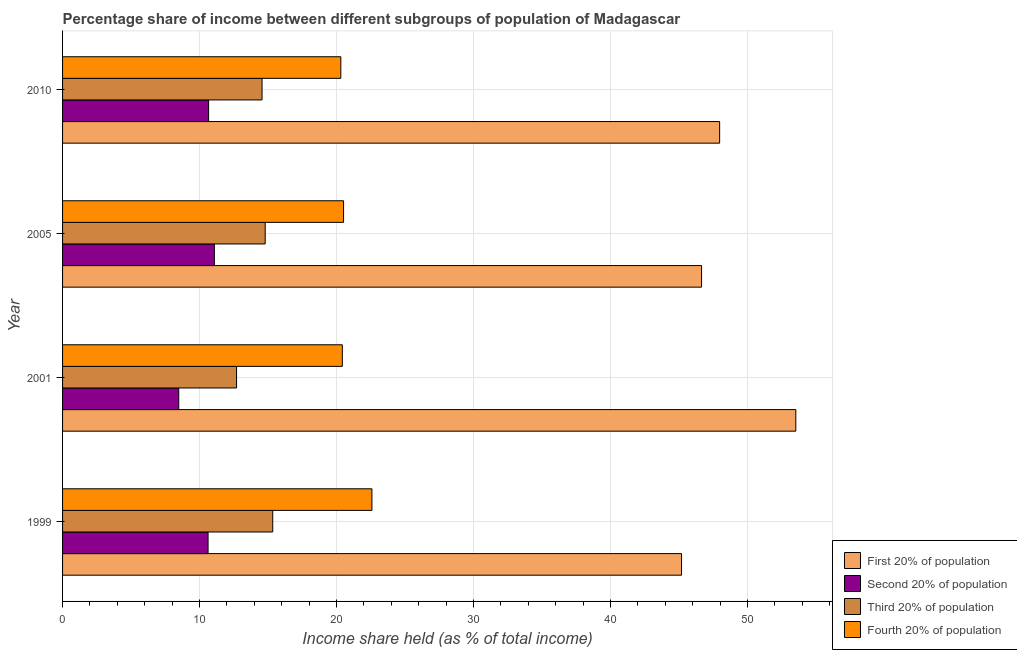How many different coloured bars are there?
Your response must be concise. 4. How many groups of bars are there?
Give a very brief answer. 4. Are the number of bars on each tick of the Y-axis equal?
Make the answer very short. Yes. How many bars are there on the 2nd tick from the bottom?
Provide a succinct answer. 4. What is the label of the 1st group of bars from the top?
Your answer should be very brief. 2010. What is the share of the income held by second 20% of the population in 2010?
Provide a succinct answer. 10.66. Across all years, what is the maximum share of the income held by first 20% of the population?
Your response must be concise. 53.52. Across all years, what is the minimum share of the income held by fourth 20% of the population?
Offer a very short reply. 20.31. What is the total share of the income held by third 20% of the population in the graph?
Offer a terse response. 57.39. What is the difference between the share of the income held by second 20% of the population in 2005 and that in 2010?
Your answer should be very brief. 0.42. What is the difference between the share of the income held by third 20% of the population in 2005 and the share of the income held by first 20% of the population in 2010?
Your answer should be compact. -33.17. What is the average share of the income held by second 20% of the population per year?
Your answer should be compact. 10.21. In the year 2005, what is the difference between the share of the income held by second 20% of the population and share of the income held by third 20% of the population?
Offer a terse response. -3.71. Is the difference between the share of the income held by second 20% of the population in 1999 and 2005 greater than the difference between the share of the income held by first 20% of the population in 1999 and 2005?
Provide a succinct answer. Yes. What is the difference between the highest and the second highest share of the income held by third 20% of the population?
Your answer should be compact. 0.55. What is the difference between the highest and the lowest share of the income held by third 20% of the population?
Ensure brevity in your answer.  2.64. Is it the case that in every year, the sum of the share of the income held by second 20% of the population and share of the income held by third 20% of the population is greater than the sum of share of the income held by first 20% of the population and share of the income held by fourth 20% of the population?
Your response must be concise. No. What does the 4th bar from the top in 2005 represents?
Provide a short and direct response. First 20% of population. What does the 3rd bar from the bottom in 1999 represents?
Your response must be concise. Third 20% of population. Is it the case that in every year, the sum of the share of the income held by first 20% of the population and share of the income held by second 20% of the population is greater than the share of the income held by third 20% of the population?
Ensure brevity in your answer.  Yes. Are all the bars in the graph horizontal?
Provide a short and direct response. Yes. Are the values on the major ticks of X-axis written in scientific E-notation?
Offer a very short reply. No. How many legend labels are there?
Make the answer very short. 4. What is the title of the graph?
Your answer should be compact. Percentage share of income between different subgroups of population of Madagascar. What is the label or title of the X-axis?
Give a very brief answer. Income share held (as % of total income). What is the label or title of the Y-axis?
Provide a succinct answer. Year. What is the Income share held (as % of total income) of First 20% of population in 1999?
Make the answer very short. 45.18. What is the Income share held (as % of total income) of Second 20% of population in 1999?
Keep it short and to the point. 10.62. What is the Income share held (as % of total income) in Third 20% of population in 1999?
Give a very brief answer. 15.34. What is the Income share held (as % of total income) of Fourth 20% of population in 1999?
Keep it short and to the point. 22.58. What is the Income share held (as % of total income) of First 20% of population in 2001?
Your response must be concise. 53.52. What is the Income share held (as % of total income) of Second 20% of population in 2001?
Provide a succinct answer. 8.48. What is the Income share held (as % of total income) in Fourth 20% of population in 2001?
Give a very brief answer. 20.42. What is the Income share held (as % of total income) of First 20% of population in 2005?
Offer a very short reply. 46.64. What is the Income share held (as % of total income) in Second 20% of population in 2005?
Provide a succinct answer. 11.08. What is the Income share held (as % of total income) of Third 20% of population in 2005?
Your response must be concise. 14.79. What is the Income share held (as % of total income) in Fourth 20% of population in 2005?
Ensure brevity in your answer.  20.51. What is the Income share held (as % of total income) in First 20% of population in 2010?
Your answer should be compact. 47.96. What is the Income share held (as % of total income) of Second 20% of population in 2010?
Your answer should be compact. 10.66. What is the Income share held (as % of total income) in Third 20% of population in 2010?
Give a very brief answer. 14.56. What is the Income share held (as % of total income) in Fourth 20% of population in 2010?
Give a very brief answer. 20.31. Across all years, what is the maximum Income share held (as % of total income) of First 20% of population?
Provide a succinct answer. 53.52. Across all years, what is the maximum Income share held (as % of total income) in Second 20% of population?
Provide a short and direct response. 11.08. Across all years, what is the maximum Income share held (as % of total income) of Third 20% of population?
Offer a terse response. 15.34. Across all years, what is the maximum Income share held (as % of total income) in Fourth 20% of population?
Your response must be concise. 22.58. Across all years, what is the minimum Income share held (as % of total income) in First 20% of population?
Offer a terse response. 45.18. Across all years, what is the minimum Income share held (as % of total income) in Second 20% of population?
Your response must be concise. 8.48. Across all years, what is the minimum Income share held (as % of total income) of Third 20% of population?
Your response must be concise. 12.7. Across all years, what is the minimum Income share held (as % of total income) of Fourth 20% of population?
Your response must be concise. 20.31. What is the total Income share held (as % of total income) of First 20% of population in the graph?
Your answer should be compact. 193.3. What is the total Income share held (as % of total income) in Second 20% of population in the graph?
Offer a very short reply. 40.84. What is the total Income share held (as % of total income) of Third 20% of population in the graph?
Provide a succinct answer. 57.39. What is the total Income share held (as % of total income) of Fourth 20% of population in the graph?
Your answer should be very brief. 83.82. What is the difference between the Income share held (as % of total income) in First 20% of population in 1999 and that in 2001?
Your response must be concise. -8.34. What is the difference between the Income share held (as % of total income) in Second 20% of population in 1999 and that in 2001?
Provide a succinct answer. 2.14. What is the difference between the Income share held (as % of total income) of Third 20% of population in 1999 and that in 2001?
Ensure brevity in your answer.  2.64. What is the difference between the Income share held (as % of total income) in Fourth 20% of population in 1999 and that in 2001?
Make the answer very short. 2.16. What is the difference between the Income share held (as % of total income) of First 20% of population in 1999 and that in 2005?
Give a very brief answer. -1.46. What is the difference between the Income share held (as % of total income) in Second 20% of population in 1999 and that in 2005?
Your answer should be compact. -0.46. What is the difference between the Income share held (as % of total income) of Third 20% of population in 1999 and that in 2005?
Your answer should be very brief. 0.55. What is the difference between the Income share held (as % of total income) in Fourth 20% of population in 1999 and that in 2005?
Offer a terse response. 2.07. What is the difference between the Income share held (as % of total income) of First 20% of population in 1999 and that in 2010?
Offer a very short reply. -2.78. What is the difference between the Income share held (as % of total income) in Second 20% of population in 1999 and that in 2010?
Offer a terse response. -0.04. What is the difference between the Income share held (as % of total income) of Third 20% of population in 1999 and that in 2010?
Ensure brevity in your answer.  0.78. What is the difference between the Income share held (as % of total income) of Fourth 20% of population in 1999 and that in 2010?
Offer a very short reply. 2.27. What is the difference between the Income share held (as % of total income) of First 20% of population in 2001 and that in 2005?
Provide a short and direct response. 6.88. What is the difference between the Income share held (as % of total income) in Second 20% of population in 2001 and that in 2005?
Your response must be concise. -2.6. What is the difference between the Income share held (as % of total income) of Third 20% of population in 2001 and that in 2005?
Give a very brief answer. -2.09. What is the difference between the Income share held (as % of total income) of Fourth 20% of population in 2001 and that in 2005?
Give a very brief answer. -0.09. What is the difference between the Income share held (as % of total income) in First 20% of population in 2001 and that in 2010?
Your answer should be very brief. 5.56. What is the difference between the Income share held (as % of total income) of Second 20% of population in 2001 and that in 2010?
Your response must be concise. -2.18. What is the difference between the Income share held (as % of total income) in Third 20% of population in 2001 and that in 2010?
Your answer should be compact. -1.86. What is the difference between the Income share held (as % of total income) in Fourth 20% of population in 2001 and that in 2010?
Provide a succinct answer. 0.11. What is the difference between the Income share held (as % of total income) in First 20% of population in 2005 and that in 2010?
Provide a succinct answer. -1.32. What is the difference between the Income share held (as % of total income) in Second 20% of population in 2005 and that in 2010?
Provide a succinct answer. 0.42. What is the difference between the Income share held (as % of total income) of Third 20% of population in 2005 and that in 2010?
Your response must be concise. 0.23. What is the difference between the Income share held (as % of total income) in Fourth 20% of population in 2005 and that in 2010?
Give a very brief answer. 0.2. What is the difference between the Income share held (as % of total income) of First 20% of population in 1999 and the Income share held (as % of total income) of Second 20% of population in 2001?
Keep it short and to the point. 36.7. What is the difference between the Income share held (as % of total income) in First 20% of population in 1999 and the Income share held (as % of total income) in Third 20% of population in 2001?
Offer a terse response. 32.48. What is the difference between the Income share held (as % of total income) of First 20% of population in 1999 and the Income share held (as % of total income) of Fourth 20% of population in 2001?
Your response must be concise. 24.76. What is the difference between the Income share held (as % of total income) in Second 20% of population in 1999 and the Income share held (as % of total income) in Third 20% of population in 2001?
Offer a very short reply. -2.08. What is the difference between the Income share held (as % of total income) in Third 20% of population in 1999 and the Income share held (as % of total income) in Fourth 20% of population in 2001?
Offer a terse response. -5.08. What is the difference between the Income share held (as % of total income) in First 20% of population in 1999 and the Income share held (as % of total income) in Second 20% of population in 2005?
Keep it short and to the point. 34.1. What is the difference between the Income share held (as % of total income) in First 20% of population in 1999 and the Income share held (as % of total income) in Third 20% of population in 2005?
Provide a succinct answer. 30.39. What is the difference between the Income share held (as % of total income) of First 20% of population in 1999 and the Income share held (as % of total income) of Fourth 20% of population in 2005?
Offer a very short reply. 24.67. What is the difference between the Income share held (as % of total income) of Second 20% of population in 1999 and the Income share held (as % of total income) of Third 20% of population in 2005?
Keep it short and to the point. -4.17. What is the difference between the Income share held (as % of total income) of Second 20% of population in 1999 and the Income share held (as % of total income) of Fourth 20% of population in 2005?
Make the answer very short. -9.89. What is the difference between the Income share held (as % of total income) in Third 20% of population in 1999 and the Income share held (as % of total income) in Fourth 20% of population in 2005?
Your response must be concise. -5.17. What is the difference between the Income share held (as % of total income) of First 20% of population in 1999 and the Income share held (as % of total income) of Second 20% of population in 2010?
Keep it short and to the point. 34.52. What is the difference between the Income share held (as % of total income) in First 20% of population in 1999 and the Income share held (as % of total income) in Third 20% of population in 2010?
Keep it short and to the point. 30.62. What is the difference between the Income share held (as % of total income) of First 20% of population in 1999 and the Income share held (as % of total income) of Fourth 20% of population in 2010?
Offer a terse response. 24.87. What is the difference between the Income share held (as % of total income) in Second 20% of population in 1999 and the Income share held (as % of total income) in Third 20% of population in 2010?
Ensure brevity in your answer.  -3.94. What is the difference between the Income share held (as % of total income) in Second 20% of population in 1999 and the Income share held (as % of total income) in Fourth 20% of population in 2010?
Give a very brief answer. -9.69. What is the difference between the Income share held (as % of total income) of Third 20% of population in 1999 and the Income share held (as % of total income) of Fourth 20% of population in 2010?
Your answer should be very brief. -4.97. What is the difference between the Income share held (as % of total income) of First 20% of population in 2001 and the Income share held (as % of total income) of Second 20% of population in 2005?
Keep it short and to the point. 42.44. What is the difference between the Income share held (as % of total income) of First 20% of population in 2001 and the Income share held (as % of total income) of Third 20% of population in 2005?
Offer a terse response. 38.73. What is the difference between the Income share held (as % of total income) in First 20% of population in 2001 and the Income share held (as % of total income) in Fourth 20% of population in 2005?
Provide a short and direct response. 33.01. What is the difference between the Income share held (as % of total income) of Second 20% of population in 2001 and the Income share held (as % of total income) of Third 20% of population in 2005?
Give a very brief answer. -6.31. What is the difference between the Income share held (as % of total income) in Second 20% of population in 2001 and the Income share held (as % of total income) in Fourth 20% of population in 2005?
Give a very brief answer. -12.03. What is the difference between the Income share held (as % of total income) of Third 20% of population in 2001 and the Income share held (as % of total income) of Fourth 20% of population in 2005?
Ensure brevity in your answer.  -7.81. What is the difference between the Income share held (as % of total income) in First 20% of population in 2001 and the Income share held (as % of total income) in Second 20% of population in 2010?
Your answer should be very brief. 42.86. What is the difference between the Income share held (as % of total income) of First 20% of population in 2001 and the Income share held (as % of total income) of Third 20% of population in 2010?
Offer a very short reply. 38.96. What is the difference between the Income share held (as % of total income) of First 20% of population in 2001 and the Income share held (as % of total income) of Fourth 20% of population in 2010?
Offer a terse response. 33.21. What is the difference between the Income share held (as % of total income) in Second 20% of population in 2001 and the Income share held (as % of total income) in Third 20% of population in 2010?
Your answer should be compact. -6.08. What is the difference between the Income share held (as % of total income) of Second 20% of population in 2001 and the Income share held (as % of total income) of Fourth 20% of population in 2010?
Provide a succinct answer. -11.83. What is the difference between the Income share held (as % of total income) of Third 20% of population in 2001 and the Income share held (as % of total income) of Fourth 20% of population in 2010?
Keep it short and to the point. -7.61. What is the difference between the Income share held (as % of total income) in First 20% of population in 2005 and the Income share held (as % of total income) in Second 20% of population in 2010?
Your response must be concise. 35.98. What is the difference between the Income share held (as % of total income) in First 20% of population in 2005 and the Income share held (as % of total income) in Third 20% of population in 2010?
Make the answer very short. 32.08. What is the difference between the Income share held (as % of total income) of First 20% of population in 2005 and the Income share held (as % of total income) of Fourth 20% of population in 2010?
Offer a terse response. 26.33. What is the difference between the Income share held (as % of total income) of Second 20% of population in 2005 and the Income share held (as % of total income) of Third 20% of population in 2010?
Ensure brevity in your answer.  -3.48. What is the difference between the Income share held (as % of total income) of Second 20% of population in 2005 and the Income share held (as % of total income) of Fourth 20% of population in 2010?
Make the answer very short. -9.23. What is the difference between the Income share held (as % of total income) in Third 20% of population in 2005 and the Income share held (as % of total income) in Fourth 20% of population in 2010?
Make the answer very short. -5.52. What is the average Income share held (as % of total income) in First 20% of population per year?
Your answer should be compact. 48.33. What is the average Income share held (as % of total income) in Second 20% of population per year?
Provide a short and direct response. 10.21. What is the average Income share held (as % of total income) of Third 20% of population per year?
Your answer should be compact. 14.35. What is the average Income share held (as % of total income) of Fourth 20% of population per year?
Offer a terse response. 20.95. In the year 1999, what is the difference between the Income share held (as % of total income) of First 20% of population and Income share held (as % of total income) of Second 20% of population?
Offer a very short reply. 34.56. In the year 1999, what is the difference between the Income share held (as % of total income) in First 20% of population and Income share held (as % of total income) in Third 20% of population?
Offer a very short reply. 29.84. In the year 1999, what is the difference between the Income share held (as % of total income) of First 20% of population and Income share held (as % of total income) of Fourth 20% of population?
Your answer should be very brief. 22.6. In the year 1999, what is the difference between the Income share held (as % of total income) of Second 20% of population and Income share held (as % of total income) of Third 20% of population?
Give a very brief answer. -4.72. In the year 1999, what is the difference between the Income share held (as % of total income) of Second 20% of population and Income share held (as % of total income) of Fourth 20% of population?
Ensure brevity in your answer.  -11.96. In the year 1999, what is the difference between the Income share held (as % of total income) of Third 20% of population and Income share held (as % of total income) of Fourth 20% of population?
Provide a succinct answer. -7.24. In the year 2001, what is the difference between the Income share held (as % of total income) of First 20% of population and Income share held (as % of total income) of Second 20% of population?
Your answer should be compact. 45.04. In the year 2001, what is the difference between the Income share held (as % of total income) in First 20% of population and Income share held (as % of total income) in Third 20% of population?
Provide a short and direct response. 40.82. In the year 2001, what is the difference between the Income share held (as % of total income) of First 20% of population and Income share held (as % of total income) of Fourth 20% of population?
Your response must be concise. 33.1. In the year 2001, what is the difference between the Income share held (as % of total income) of Second 20% of population and Income share held (as % of total income) of Third 20% of population?
Keep it short and to the point. -4.22. In the year 2001, what is the difference between the Income share held (as % of total income) in Second 20% of population and Income share held (as % of total income) in Fourth 20% of population?
Give a very brief answer. -11.94. In the year 2001, what is the difference between the Income share held (as % of total income) of Third 20% of population and Income share held (as % of total income) of Fourth 20% of population?
Make the answer very short. -7.72. In the year 2005, what is the difference between the Income share held (as % of total income) in First 20% of population and Income share held (as % of total income) in Second 20% of population?
Keep it short and to the point. 35.56. In the year 2005, what is the difference between the Income share held (as % of total income) in First 20% of population and Income share held (as % of total income) in Third 20% of population?
Provide a short and direct response. 31.85. In the year 2005, what is the difference between the Income share held (as % of total income) in First 20% of population and Income share held (as % of total income) in Fourth 20% of population?
Keep it short and to the point. 26.13. In the year 2005, what is the difference between the Income share held (as % of total income) of Second 20% of population and Income share held (as % of total income) of Third 20% of population?
Provide a short and direct response. -3.71. In the year 2005, what is the difference between the Income share held (as % of total income) of Second 20% of population and Income share held (as % of total income) of Fourth 20% of population?
Offer a terse response. -9.43. In the year 2005, what is the difference between the Income share held (as % of total income) in Third 20% of population and Income share held (as % of total income) in Fourth 20% of population?
Provide a short and direct response. -5.72. In the year 2010, what is the difference between the Income share held (as % of total income) of First 20% of population and Income share held (as % of total income) of Second 20% of population?
Provide a succinct answer. 37.3. In the year 2010, what is the difference between the Income share held (as % of total income) in First 20% of population and Income share held (as % of total income) in Third 20% of population?
Ensure brevity in your answer.  33.4. In the year 2010, what is the difference between the Income share held (as % of total income) in First 20% of population and Income share held (as % of total income) in Fourth 20% of population?
Keep it short and to the point. 27.65. In the year 2010, what is the difference between the Income share held (as % of total income) of Second 20% of population and Income share held (as % of total income) of Third 20% of population?
Offer a very short reply. -3.9. In the year 2010, what is the difference between the Income share held (as % of total income) in Second 20% of population and Income share held (as % of total income) in Fourth 20% of population?
Your answer should be very brief. -9.65. In the year 2010, what is the difference between the Income share held (as % of total income) of Third 20% of population and Income share held (as % of total income) of Fourth 20% of population?
Your answer should be very brief. -5.75. What is the ratio of the Income share held (as % of total income) of First 20% of population in 1999 to that in 2001?
Provide a succinct answer. 0.84. What is the ratio of the Income share held (as % of total income) in Second 20% of population in 1999 to that in 2001?
Offer a very short reply. 1.25. What is the ratio of the Income share held (as % of total income) in Third 20% of population in 1999 to that in 2001?
Make the answer very short. 1.21. What is the ratio of the Income share held (as % of total income) of Fourth 20% of population in 1999 to that in 2001?
Offer a very short reply. 1.11. What is the ratio of the Income share held (as % of total income) in First 20% of population in 1999 to that in 2005?
Offer a terse response. 0.97. What is the ratio of the Income share held (as % of total income) of Second 20% of population in 1999 to that in 2005?
Keep it short and to the point. 0.96. What is the ratio of the Income share held (as % of total income) in Third 20% of population in 1999 to that in 2005?
Your answer should be compact. 1.04. What is the ratio of the Income share held (as % of total income) of Fourth 20% of population in 1999 to that in 2005?
Your answer should be compact. 1.1. What is the ratio of the Income share held (as % of total income) in First 20% of population in 1999 to that in 2010?
Offer a terse response. 0.94. What is the ratio of the Income share held (as % of total income) in Second 20% of population in 1999 to that in 2010?
Provide a short and direct response. 1. What is the ratio of the Income share held (as % of total income) of Third 20% of population in 1999 to that in 2010?
Offer a terse response. 1.05. What is the ratio of the Income share held (as % of total income) of Fourth 20% of population in 1999 to that in 2010?
Provide a succinct answer. 1.11. What is the ratio of the Income share held (as % of total income) in First 20% of population in 2001 to that in 2005?
Provide a succinct answer. 1.15. What is the ratio of the Income share held (as % of total income) in Second 20% of population in 2001 to that in 2005?
Offer a terse response. 0.77. What is the ratio of the Income share held (as % of total income) in Third 20% of population in 2001 to that in 2005?
Offer a very short reply. 0.86. What is the ratio of the Income share held (as % of total income) in Fourth 20% of population in 2001 to that in 2005?
Give a very brief answer. 1. What is the ratio of the Income share held (as % of total income) in First 20% of population in 2001 to that in 2010?
Your answer should be very brief. 1.12. What is the ratio of the Income share held (as % of total income) of Second 20% of population in 2001 to that in 2010?
Give a very brief answer. 0.8. What is the ratio of the Income share held (as % of total income) in Third 20% of population in 2001 to that in 2010?
Your answer should be compact. 0.87. What is the ratio of the Income share held (as % of total income) of Fourth 20% of population in 2001 to that in 2010?
Make the answer very short. 1.01. What is the ratio of the Income share held (as % of total income) of First 20% of population in 2005 to that in 2010?
Provide a succinct answer. 0.97. What is the ratio of the Income share held (as % of total income) of Second 20% of population in 2005 to that in 2010?
Give a very brief answer. 1.04. What is the ratio of the Income share held (as % of total income) of Third 20% of population in 2005 to that in 2010?
Your answer should be compact. 1.02. What is the ratio of the Income share held (as % of total income) in Fourth 20% of population in 2005 to that in 2010?
Give a very brief answer. 1.01. What is the difference between the highest and the second highest Income share held (as % of total income) in First 20% of population?
Make the answer very short. 5.56. What is the difference between the highest and the second highest Income share held (as % of total income) in Second 20% of population?
Keep it short and to the point. 0.42. What is the difference between the highest and the second highest Income share held (as % of total income) in Third 20% of population?
Keep it short and to the point. 0.55. What is the difference between the highest and the second highest Income share held (as % of total income) in Fourth 20% of population?
Offer a terse response. 2.07. What is the difference between the highest and the lowest Income share held (as % of total income) in First 20% of population?
Your answer should be very brief. 8.34. What is the difference between the highest and the lowest Income share held (as % of total income) of Third 20% of population?
Your answer should be compact. 2.64. What is the difference between the highest and the lowest Income share held (as % of total income) of Fourth 20% of population?
Offer a terse response. 2.27. 